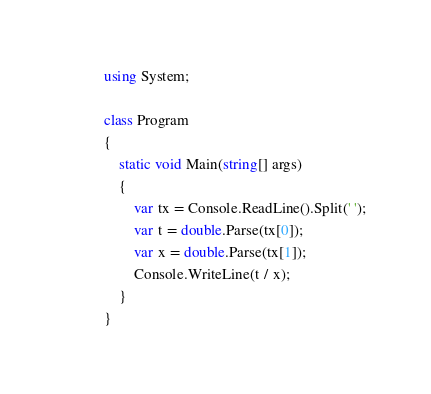Convert code to text. <code><loc_0><loc_0><loc_500><loc_500><_C#_>using System;

class Program
{
    static void Main(string[] args)
    {
        var tx = Console.ReadLine().Split(' ');
        var t = double.Parse(tx[0]);
        var x = double.Parse(tx[1]);
        Console.WriteLine(t / x);
    }
}
</code> 